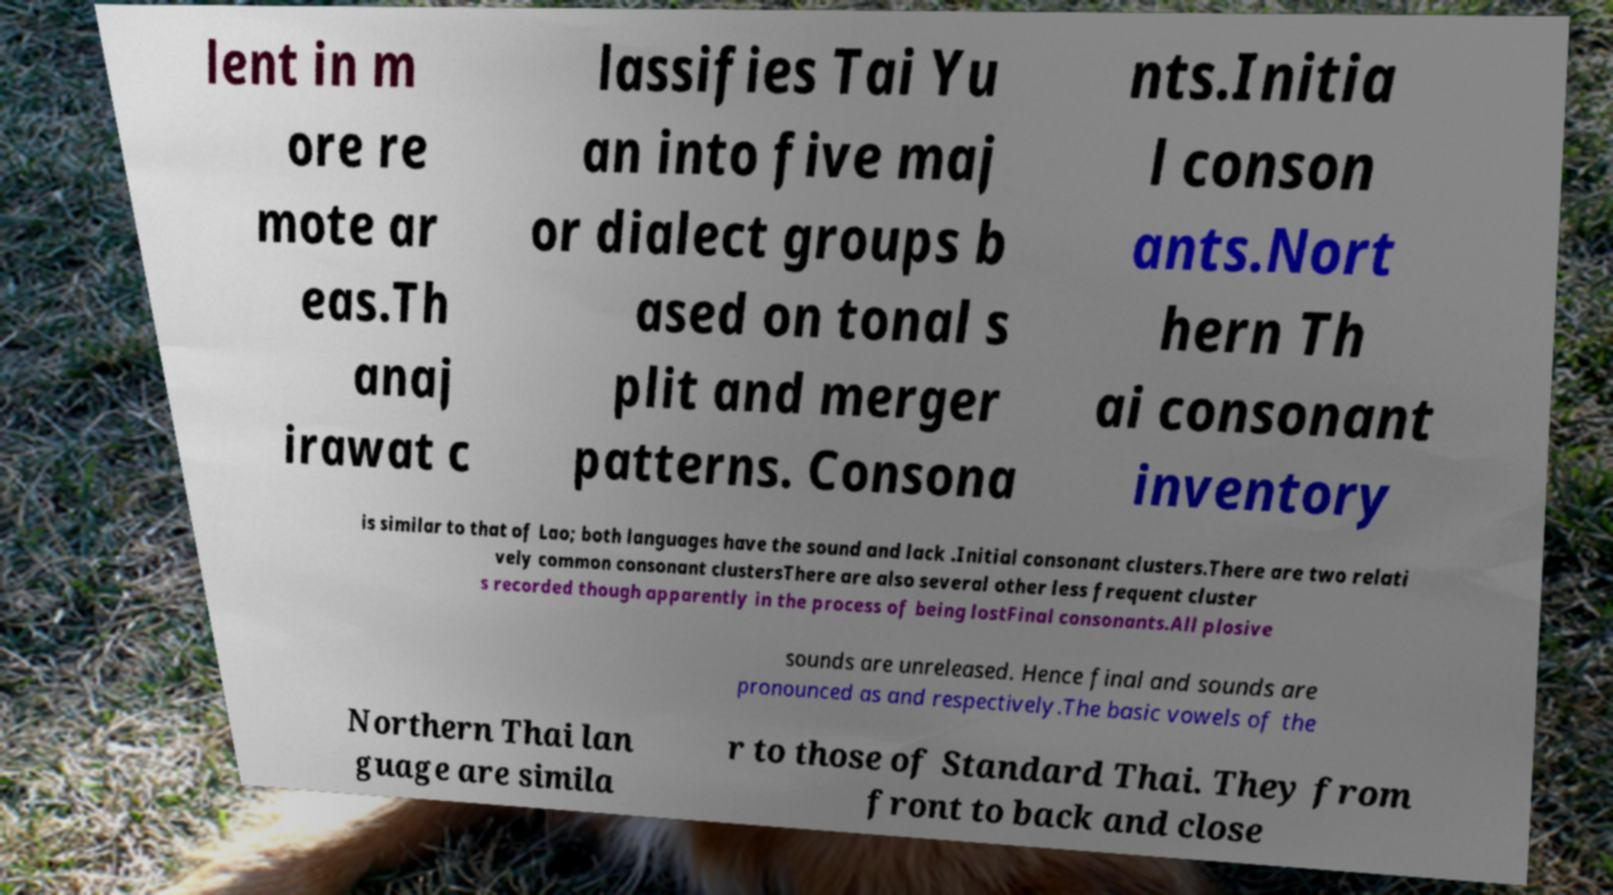Could you assist in decoding the text presented in this image and type it out clearly? lent in m ore re mote ar eas.Th anaj irawat c lassifies Tai Yu an into five maj or dialect groups b ased on tonal s plit and merger patterns. Consona nts.Initia l conson ants.Nort hern Th ai consonant inventory is similar to that of Lao; both languages have the sound and lack .Initial consonant clusters.There are two relati vely common consonant clustersThere are also several other less frequent cluster s recorded though apparently in the process of being lostFinal consonants.All plosive sounds are unreleased. Hence final and sounds are pronounced as and respectively.The basic vowels of the Northern Thai lan guage are simila r to those of Standard Thai. They from front to back and close 